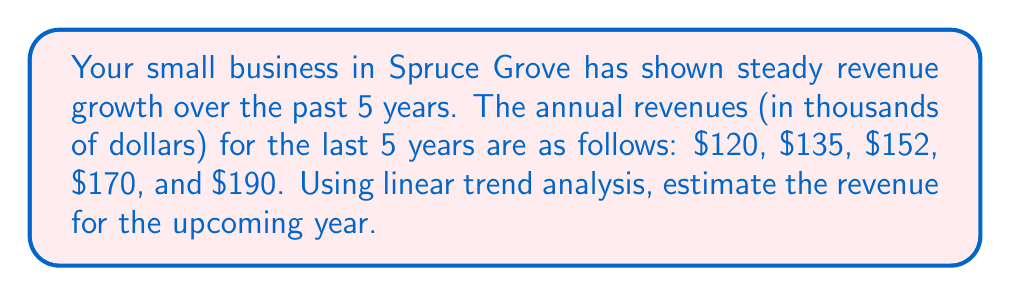Help me with this question. To estimate future revenue using trend analysis, we'll use the linear equation:
$$y = mx + b$$
Where $y$ is the revenue, $m$ is the slope (average yearly growth), $x$ is the year number, and $b$ is the y-intercept.

Step 1: Calculate the average yearly growth (slope).
$$m = \frac{\text{Total change in revenue}}{\text{Number of years - 1}} = \frac{190 - 120}{5 - 1} = \frac{70}{4} = 17.5$$

Step 2: Use two points to find the y-intercept $(b)$.
Let's use the first year $(x_1 = 1, y_1 = 120)$ and last year $(x_5 = 5, y_5 = 190)$.
$$120 = 17.5(1) + b$$
$$190 = 17.5(5) + b$$

Solving either equation:
$$b = 120 - 17.5 = 102.5$$

Step 3: Write the linear equation.
$$y = 17.5x + 102.5$$

Step 4: Estimate revenue for the upcoming year (year 6).
$$y = 17.5(6) + 102.5 = 105 + 102.5 = 207.5$$

Therefore, the estimated revenue for the upcoming year is $207,500.
Answer: $207,500 